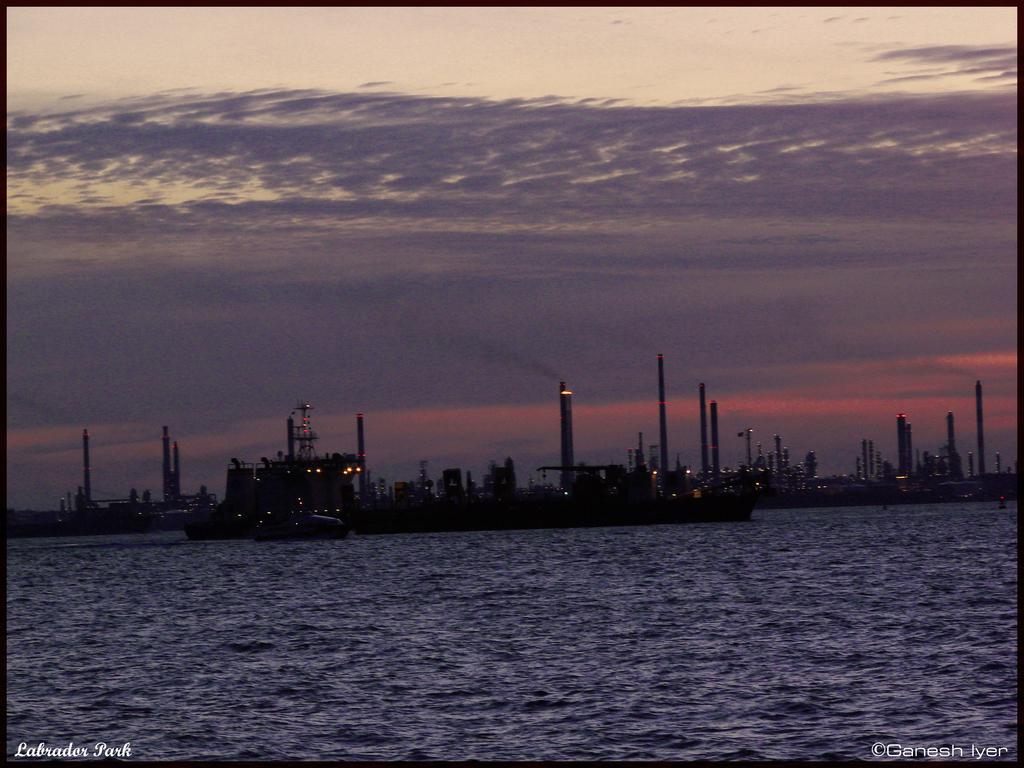What is the main subject of the image? The main subject of the image is ships. Where are the ships located in the image? The ships are on the water in the image. What can be seen in the background of the image? The sky is visible in the background of the image. Can you tell me how many tomatoes are hanging from the ships in the image? There are no tomatoes present in the image, as it features ships on the water with a visible sky in the background. What type of wrist accessory is visible on the crew members of the ships? There is no wrist accessory visible on the crew members of the ships in the image. 